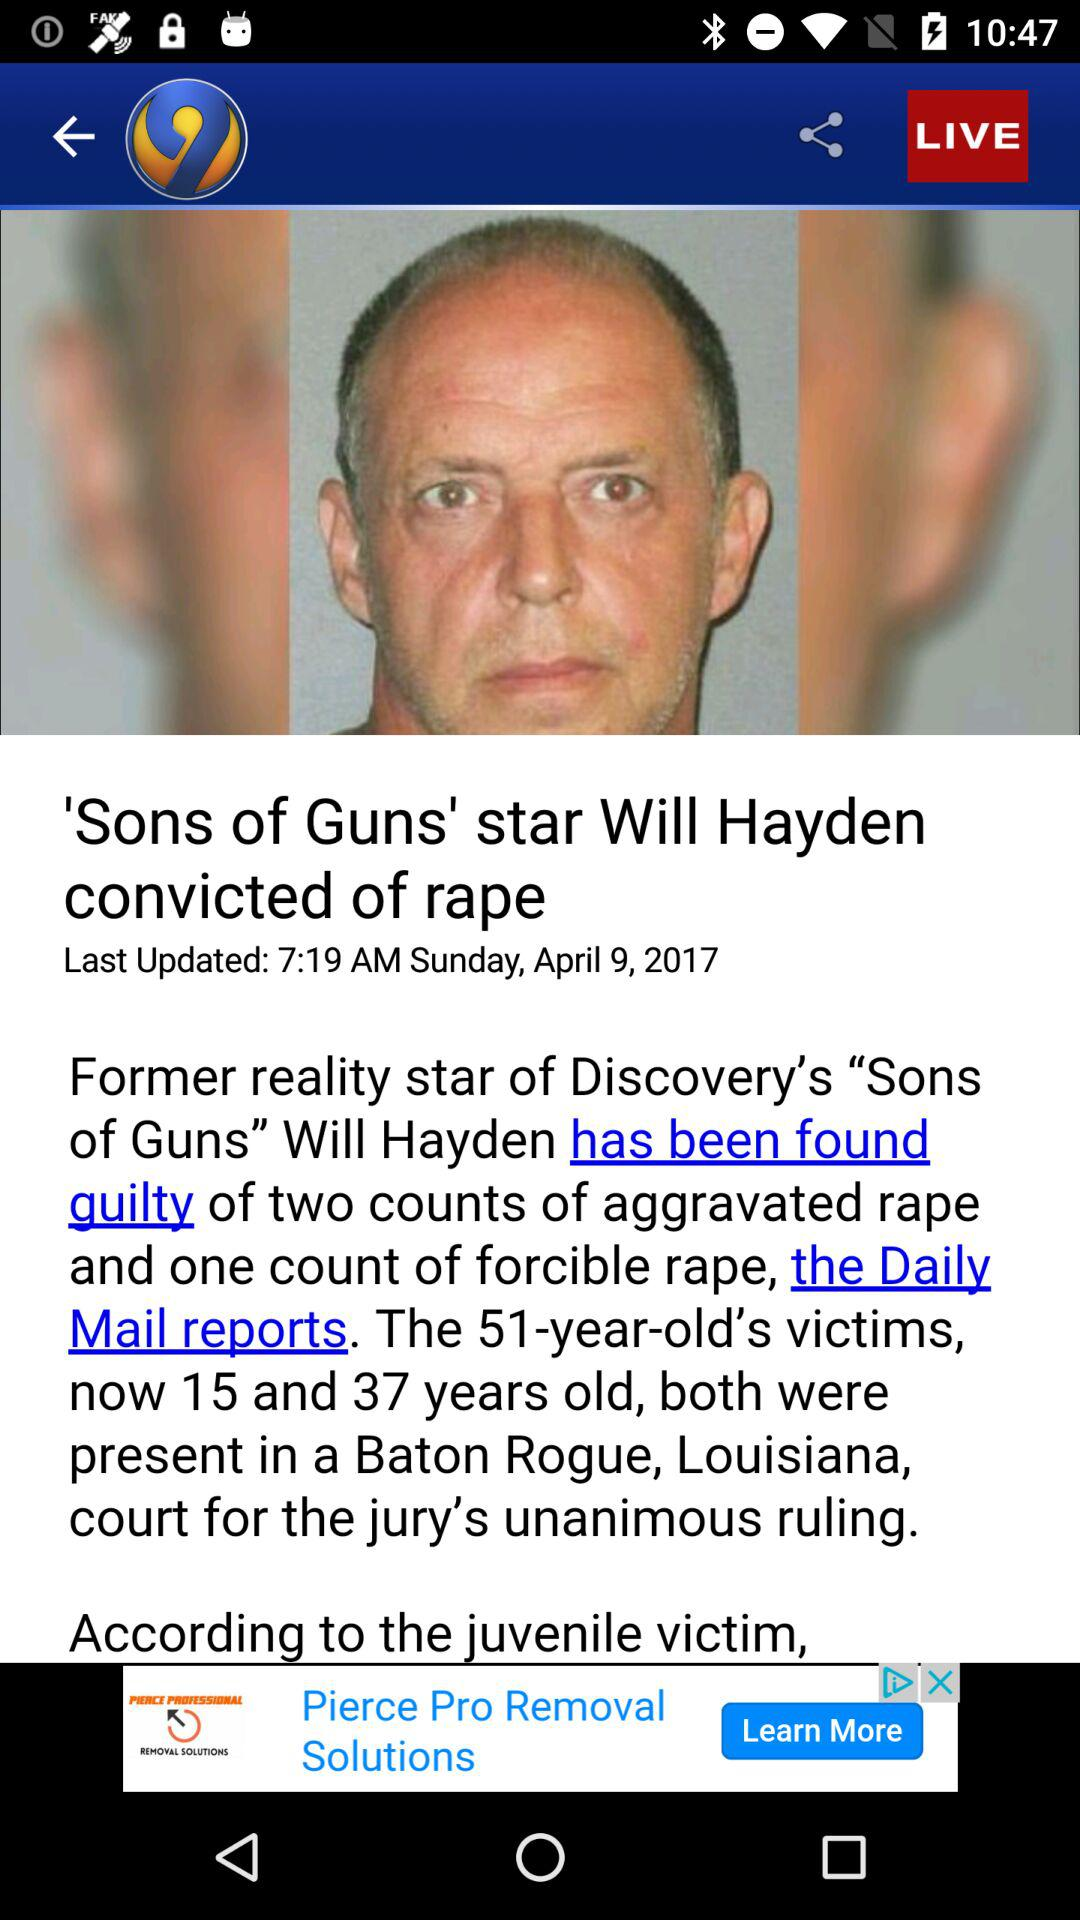How many more years old is the oldest victim than the youngest victim?
Answer the question using a single word or phrase. 22 